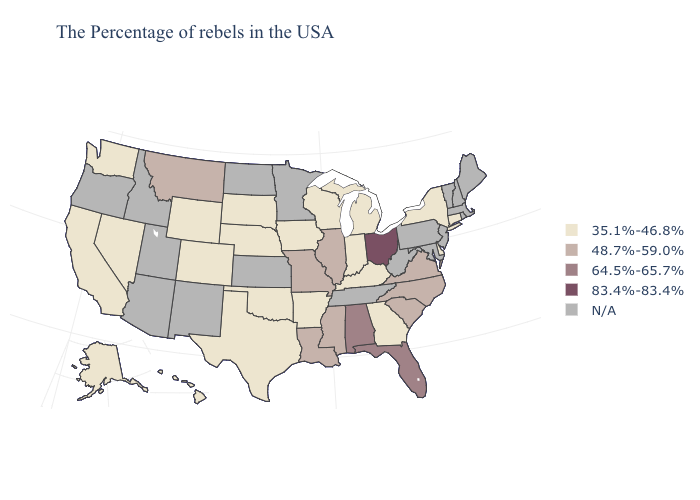What is the value of Pennsylvania?
Short answer required. N/A. What is the value of Minnesota?
Write a very short answer. N/A. What is the highest value in states that border Georgia?
Write a very short answer. 64.5%-65.7%. Which states have the lowest value in the USA?
Concise answer only. Connecticut, New York, Delaware, Georgia, Michigan, Kentucky, Indiana, Wisconsin, Arkansas, Iowa, Nebraska, Oklahoma, Texas, South Dakota, Wyoming, Colorado, Nevada, California, Washington, Alaska, Hawaii. Name the states that have a value in the range 35.1%-46.8%?
Keep it brief. Connecticut, New York, Delaware, Georgia, Michigan, Kentucky, Indiana, Wisconsin, Arkansas, Iowa, Nebraska, Oklahoma, Texas, South Dakota, Wyoming, Colorado, Nevada, California, Washington, Alaska, Hawaii. What is the value of Washington?
Write a very short answer. 35.1%-46.8%. How many symbols are there in the legend?
Concise answer only. 5. Does the first symbol in the legend represent the smallest category?
Be succinct. Yes. Which states have the lowest value in the Northeast?
Keep it brief. Connecticut, New York. Among the states that border Rhode Island , which have the highest value?
Be succinct. Connecticut. What is the value of Wyoming?
Be succinct. 35.1%-46.8%. Name the states that have a value in the range 35.1%-46.8%?
Concise answer only. Connecticut, New York, Delaware, Georgia, Michigan, Kentucky, Indiana, Wisconsin, Arkansas, Iowa, Nebraska, Oklahoma, Texas, South Dakota, Wyoming, Colorado, Nevada, California, Washington, Alaska, Hawaii. Does New York have the lowest value in the USA?
Give a very brief answer. Yes. 